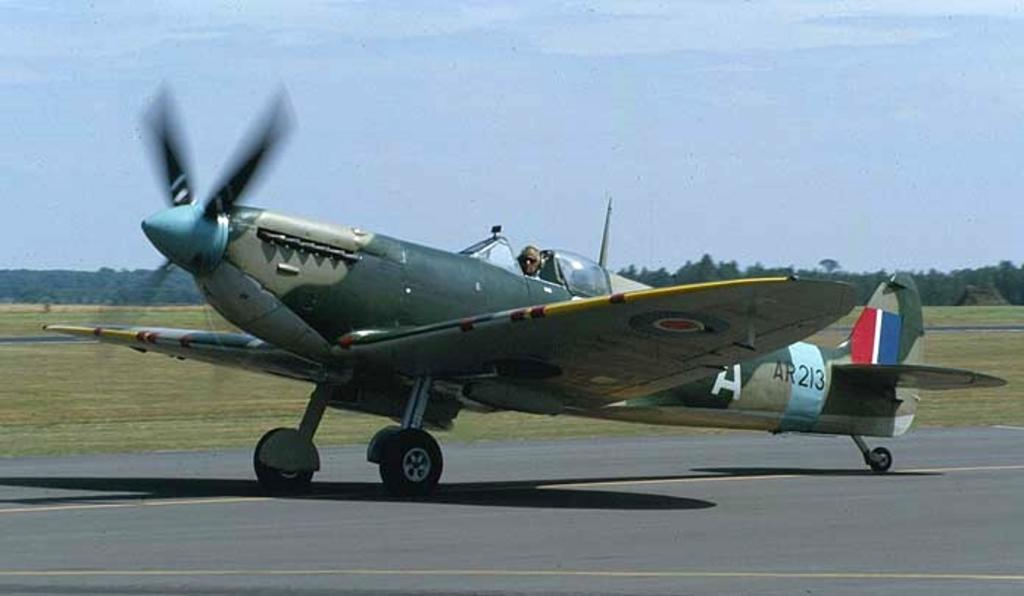Provide a one-sentence caption for the provided image. An old style plane that has AR213 written on it. 